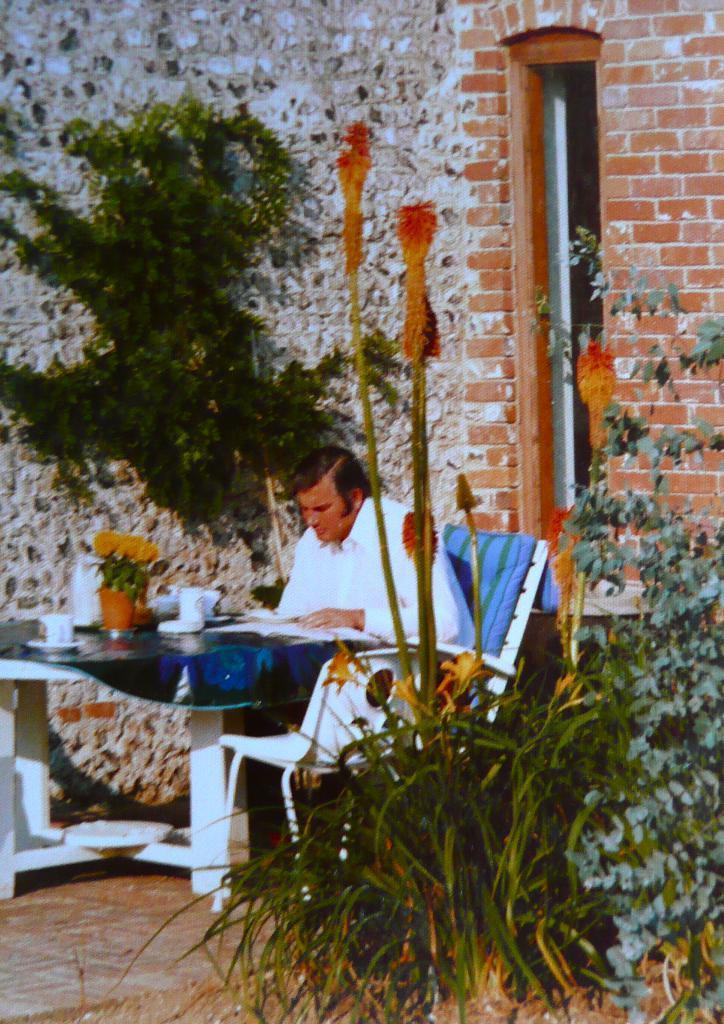Please provide a concise description of this image. Man in white shirt is sitting on chair. In front of him, we see a table on which cup, saucer, flower pot, glass and book are placed. Behind him, we see a wall which is made of brick and we even see plants and tree. 